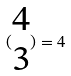Convert formula to latex. <formula><loc_0><loc_0><loc_500><loc_500>( \begin{matrix} 4 \\ 3 \end{matrix} ) = 4</formula> 